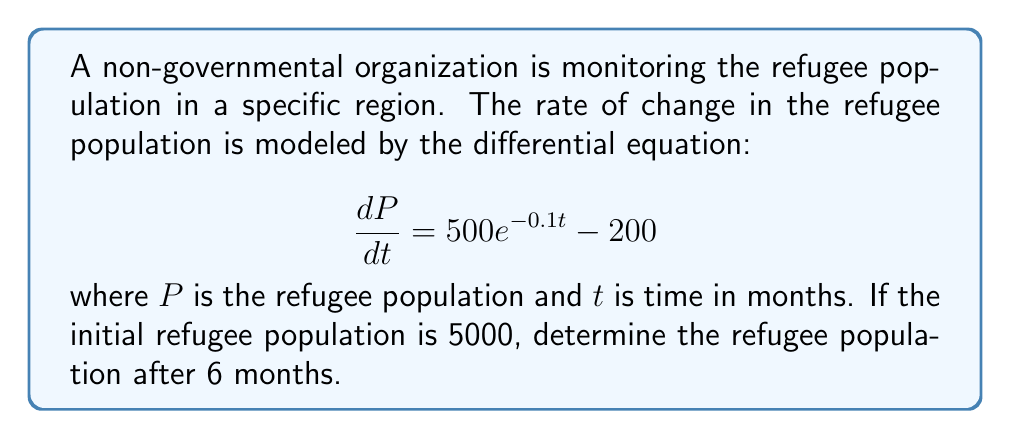Show me your answer to this math problem. To solve this first-order linear differential equation, we follow these steps:

1) The general form of the equation is:
   $$\frac{dP}{dt} = 500e^{-0.1t} - 200$$

2) To find $P(t)$, we integrate both sides with respect to $t$:
   $$P = \int (500e^{-0.1t} - 200) dt$$

3) Integrate the right-hand side:
   $$P = -5000e^{-0.1t} - 200t + C$$

4) To find the constant of integration $C$, we use the initial condition $P(0) = 5000$:
   $$5000 = -5000e^{-0.1(0)} - 200(0) + C$$
   $$5000 = -5000 + C$$
   $$C = 10000$$

5) Therefore, the general solution is:
   $$P(t) = -5000e^{-0.1t} - 200t + 10000$$

6) To find the population after 6 months, we substitute $t = 6$:
   $$P(6) = -5000e^{-0.1(6)} - 200(6) + 10000$$
   $$P(6) = -5000e^{-0.6} - 1200 + 10000$$
   $$P(6) = -2748.77 - 1200 + 10000$$
   $$P(6) = 6051.23$$
Answer: The refugee population after 6 months is approximately 6051 people. 